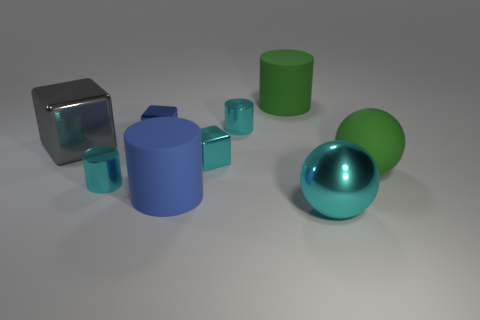Are there fewer metallic objects that are on the left side of the large cube than cylinders to the left of the cyan shiny block?
Your response must be concise. Yes. There is a green rubber thing that is left of the rubber thing that is right of the rubber cylinder behind the gray shiny block; what is its size?
Provide a short and direct response. Large. What is the size of the matte thing that is on the left side of the large cyan object and in front of the small blue thing?
Your answer should be very brief. Large. The green matte thing that is behind the large green thing that is to the right of the big cyan metal object is what shape?
Ensure brevity in your answer.  Cylinder. Is there any other thing that has the same color as the big metallic ball?
Give a very brief answer. Yes. There is a tiny cyan object that is left of the blue matte object; what shape is it?
Your response must be concise. Cylinder. There is a large matte thing that is both in front of the blue block and left of the green matte sphere; what shape is it?
Ensure brevity in your answer.  Cylinder. What number of purple things are large matte spheres or cylinders?
Your answer should be compact. 0. Do the rubber cylinder behind the blue rubber cylinder and the big rubber ball have the same color?
Your answer should be compact. Yes. What is the size of the metal cylinder that is to the right of the cyan cylinder on the left side of the blue metallic object?
Your answer should be compact. Small. 